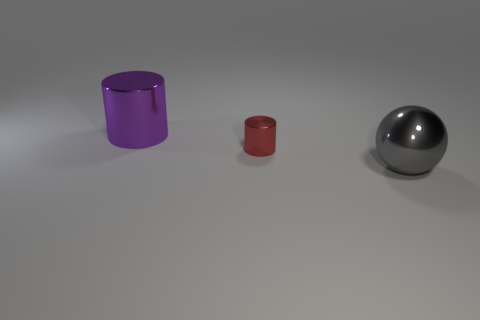Add 2 large gray shiny things. How many objects exist? 5 Subtract all spheres. How many objects are left? 2 Add 1 tiny red shiny objects. How many tiny red shiny objects are left? 2 Add 2 large metallic spheres. How many large metallic spheres exist? 3 Subtract 0 cyan cylinders. How many objects are left? 3 Subtract all small matte balls. Subtract all gray metal objects. How many objects are left? 2 